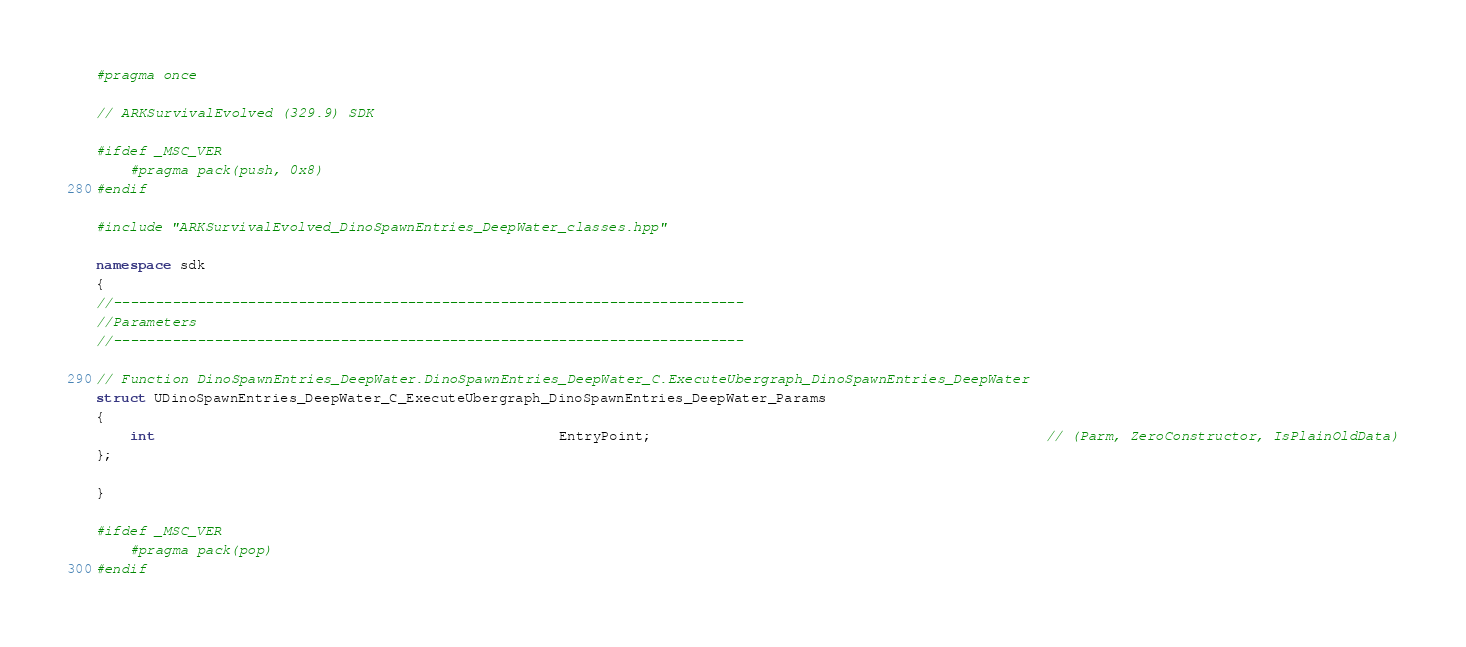Convert code to text. <code><loc_0><loc_0><loc_500><loc_500><_C++_>#pragma once

// ARKSurvivalEvolved (329.9) SDK

#ifdef _MSC_VER
	#pragma pack(push, 0x8)
#endif

#include "ARKSurvivalEvolved_DinoSpawnEntries_DeepWater_classes.hpp"

namespace sdk
{
//---------------------------------------------------------------------------
//Parameters
//---------------------------------------------------------------------------

// Function DinoSpawnEntries_DeepWater.DinoSpawnEntries_DeepWater_C.ExecuteUbergraph_DinoSpawnEntries_DeepWater
struct UDinoSpawnEntries_DeepWater_C_ExecuteUbergraph_DinoSpawnEntries_DeepWater_Params
{
	int                                                EntryPoint;                                               // (Parm, ZeroConstructor, IsPlainOldData)
};

}

#ifdef _MSC_VER
	#pragma pack(pop)
#endif
</code> 